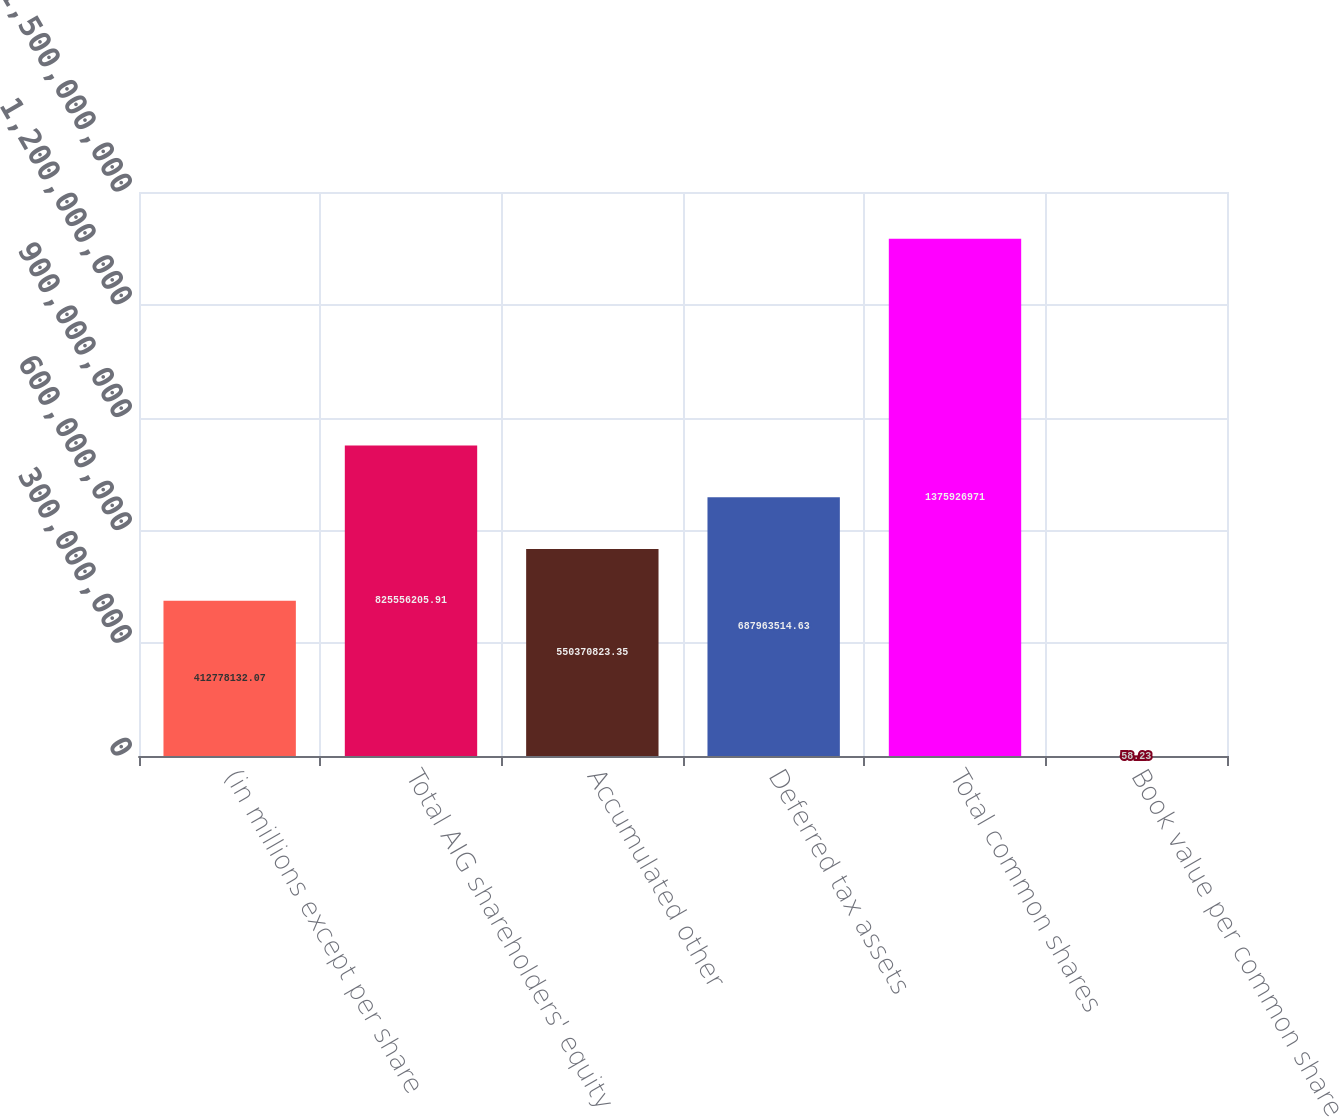Convert chart. <chart><loc_0><loc_0><loc_500><loc_500><bar_chart><fcel>(in millions except per share<fcel>Total AIG shareholders' equity<fcel>Accumulated other<fcel>Deferred tax assets<fcel>Total common shares<fcel>Book value per common share<nl><fcel>4.12778e+08<fcel>8.25556e+08<fcel>5.50371e+08<fcel>6.87964e+08<fcel>1.37593e+09<fcel>58.23<nl></chart> 